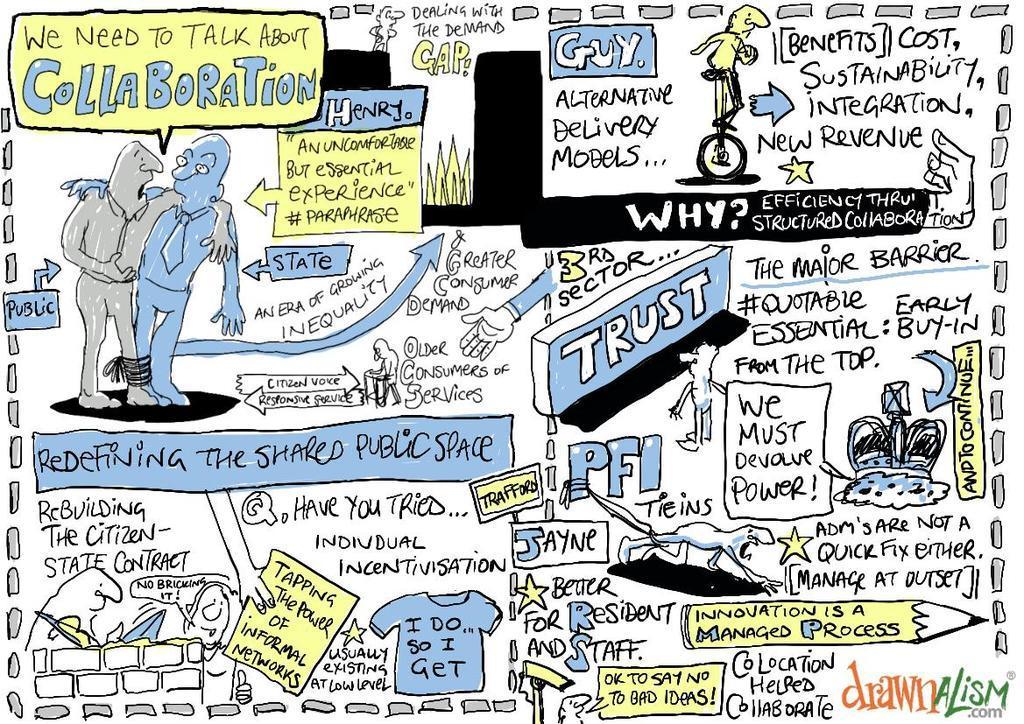Can you describe this image briefly? In this image, there is a text and sketch of persons are all over this image. 